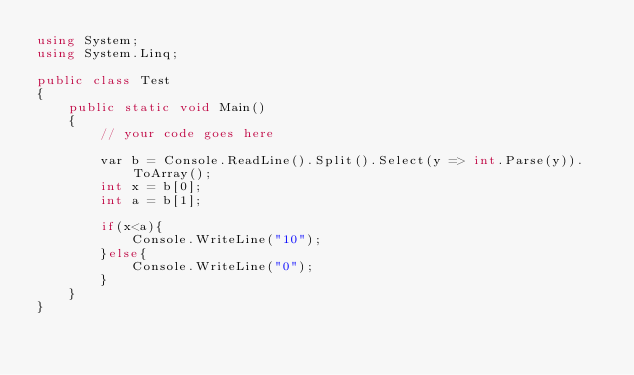Convert code to text. <code><loc_0><loc_0><loc_500><loc_500><_C#_>using System;
using System.Linq;

public class Test
{
	public static void Main()
	{
		// your code goes here
		
		var b = Console.ReadLine().Split().Select(y => int.Parse(y)).ToArray();
		int x = b[0];
		int a = b[1];
		
		if(x<a){
			Console.WriteLine("10");
		}else{
			Console.WriteLine("0");
		}
	}
}
</code> 